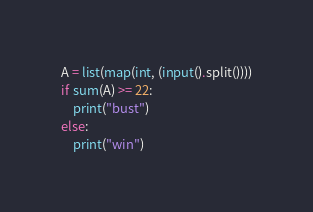Convert code to text. <code><loc_0><loc_0><loc_500><loc_500><_Python_>A = list(map(int, (input().split())))
if sum(A) >= 22:
    print("bust")
else:
    print("win")</code> 